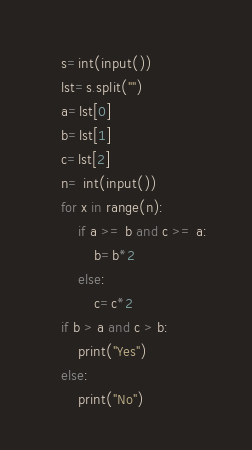Convert code to text. <code><loc_0><loc_0><loc_500><loc_500><_Python_>    s=int(input())
    lst=s.split("")
    a=lst[0]
    b=lst[1]
    c=lst[2]
    n= int(input())
    for x in range(n):
        if a >= b and c >= a:
            b=b*2
        else:
            c=c*2
    if b > a and c > b:
        print("Yes")
    else:
        print("No")</code> 